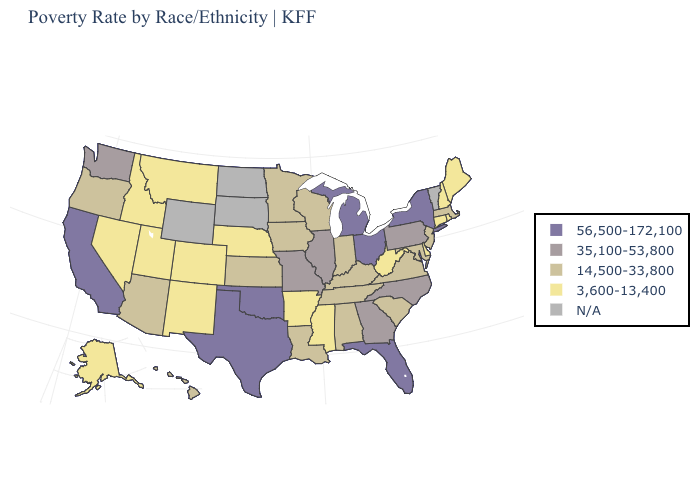Name the states that have a value in the range 3,600-13,400?
Be succinct. Alaska, Arkansas, Colorado, Connecticut, Delaware, Idaho, Maine, Mississippi, Montana, Nebraska, Nevada, New Hampshire, New Mexico, Rhode Island, Utah, West Virginia. Name the states that have a value in the range 56,500-172,100?
Give a very brief answer. California, Florida, Michigan, New York, Ohio, Oklahoma, Texas. Is the legend a continuous bar?
Short answer required. No. Among the states that border Missouri , does Tennessee have the highest value?
Give a very brief answer. No. What is the highest value in the USA?
Be succinct. 56,500-172,100. Name the states that have a value in the range 14,500-33,800?
Concise answer only. Alabama, Arizona, Hawaii, Indiana, Iowa, Kansas, Kentucky, Louisiana, Maryland, Massachusetts, Minnesota, New Jersey, Oregon, South Carolina, Tennessee, Virginia, Wisconsin. What is the lowest value in the MidWest?
Concise answer only. 3,600-13,400. Which states hav the highest value in the South?
Keep it brief. Florida, Oklahoma, Texas. Among the states that border Pennsylvania , which have the lowest value?
Give a very brief answer. Delaware, West Virginia. What is the value of Tennessee?
Concise answer only. 14,500-33,800. What is the value of West Virginia?
Write a very short answer. 3,600-13,400. Among the states that border Arkansas , which have the highest value?
Be succinct. Oklahoma, Texas. What is the value of New York?
Write a very short answer. 56,500-172,100. Does Texas have the lowest value in the USA?
Concise answer only. No. Among the states that border Pennsylvania , which have the lowest value?
Keep it brief. Delaware, West Virginia. 